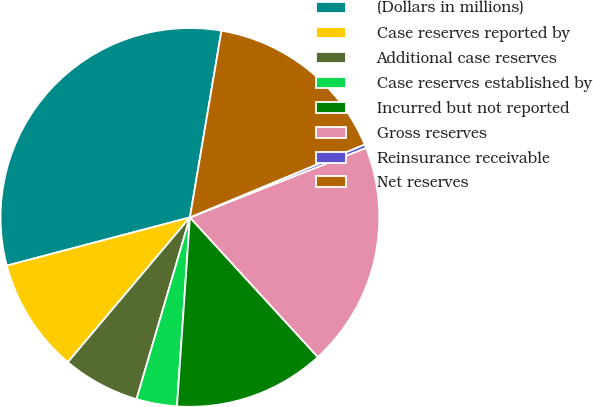Convert chart to OTSL. <chart><loc_0><loc_0><loc_500><loc_500><pie_chart><fcel>(Dollars in millions)<fcel>Case reserves reported by<fcel>Additional case reserves<fcel>Case reserves established by<fcel>Incurred but not reported<fcel>Gross reserves<fcel>Reinsurance receivable<fcel>Net reserves<nl><fcel>31.76%<fcel>9.75%<fcel>6.6%<fcel>3.46%<fcel>12.89%<fcel>19.18%<fcel>0.31%<fcel>16.04%<nl></chart> 